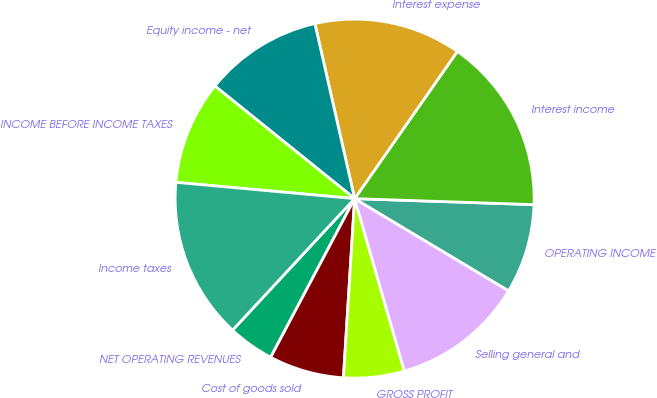Convert chart. <chart><loc_0><loc_0><loc_500><loc_500><pie_chart><fcel>NET OPERATING REVENUES<fcel>Cost of goods sold<fcel>GROSS PROFIT<fcel>Selling general and<fcel>OPERATING INCOME<fcel>Interest income<fcel>Interest expense<fcel>Equity income - net<fcel>INCOME BEFORE INCOME TAXES<fcel>Income taxes<nl><fcel>4.16%<fcel>6.75%<fcel>5.46%<fcel>11.95%<fcel>8.05%<fcel>15.84%<fcel>13.25%<fcel>10.65%<fcel>9.35%<fcel>14.54%<nl></chart> 